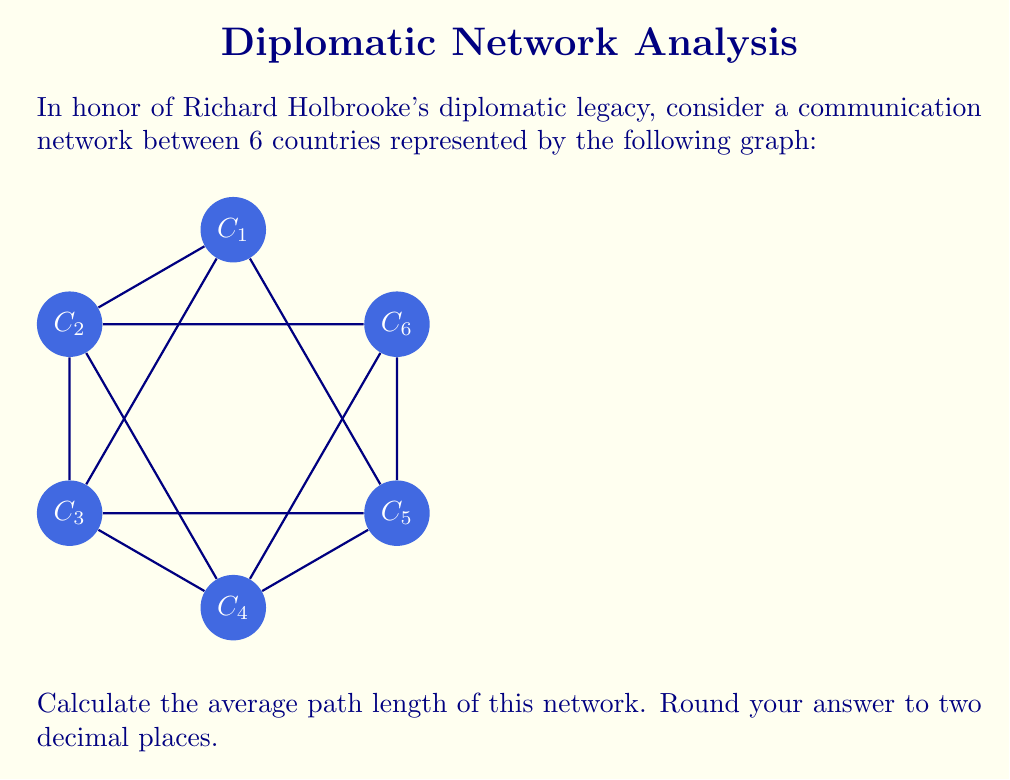Help me with this question. To calculate the average path length, we need to follow these steps:

1) First, let's calculate the distance between each pair of countries:
   - Adjacent countries have a distance of 1
   - Countries connected by a diagonal have a distance of 1
   - Countries opposite each other have a distance of 2

2) Now, let's count the number of pairs for each distance:
   - Distance 1: 9 pairs (6 edges of the hexagon + 3 diagonals)
   - Distance 2: 6 pairs (opposite vertices)

3) The total number of pairs is $\binom{6}{2} = 15$

4) The sum of all distances is:
   $$(9 \times 1) + (6 \times 2) = 9 + 12 = 21$$

5) The average path length is the sum of all distances divided by the number of pairs:

   $$\text{Average Path Length} = \frac{21}{15} = 1.4$$

6) Rounding to two decimal places: 1.40
Answer: 1.40 